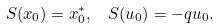Convert formula to latex. <formula><loc_0><loc_0><loc_500><loc_500>S ( x _ { 0 } ) = x ^ { * } _ { 0 } , \ \ S ( u _ { 0 } ) = - q u _ { 0 } .</formula> 